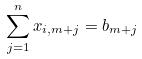Convert formula to latex. <formula><loc_0><loc_0><loc_500><loc_500>\sum _ { j = 1 } ^ { n } x _ { i , m + j } = b _ { m + j }</formula> 